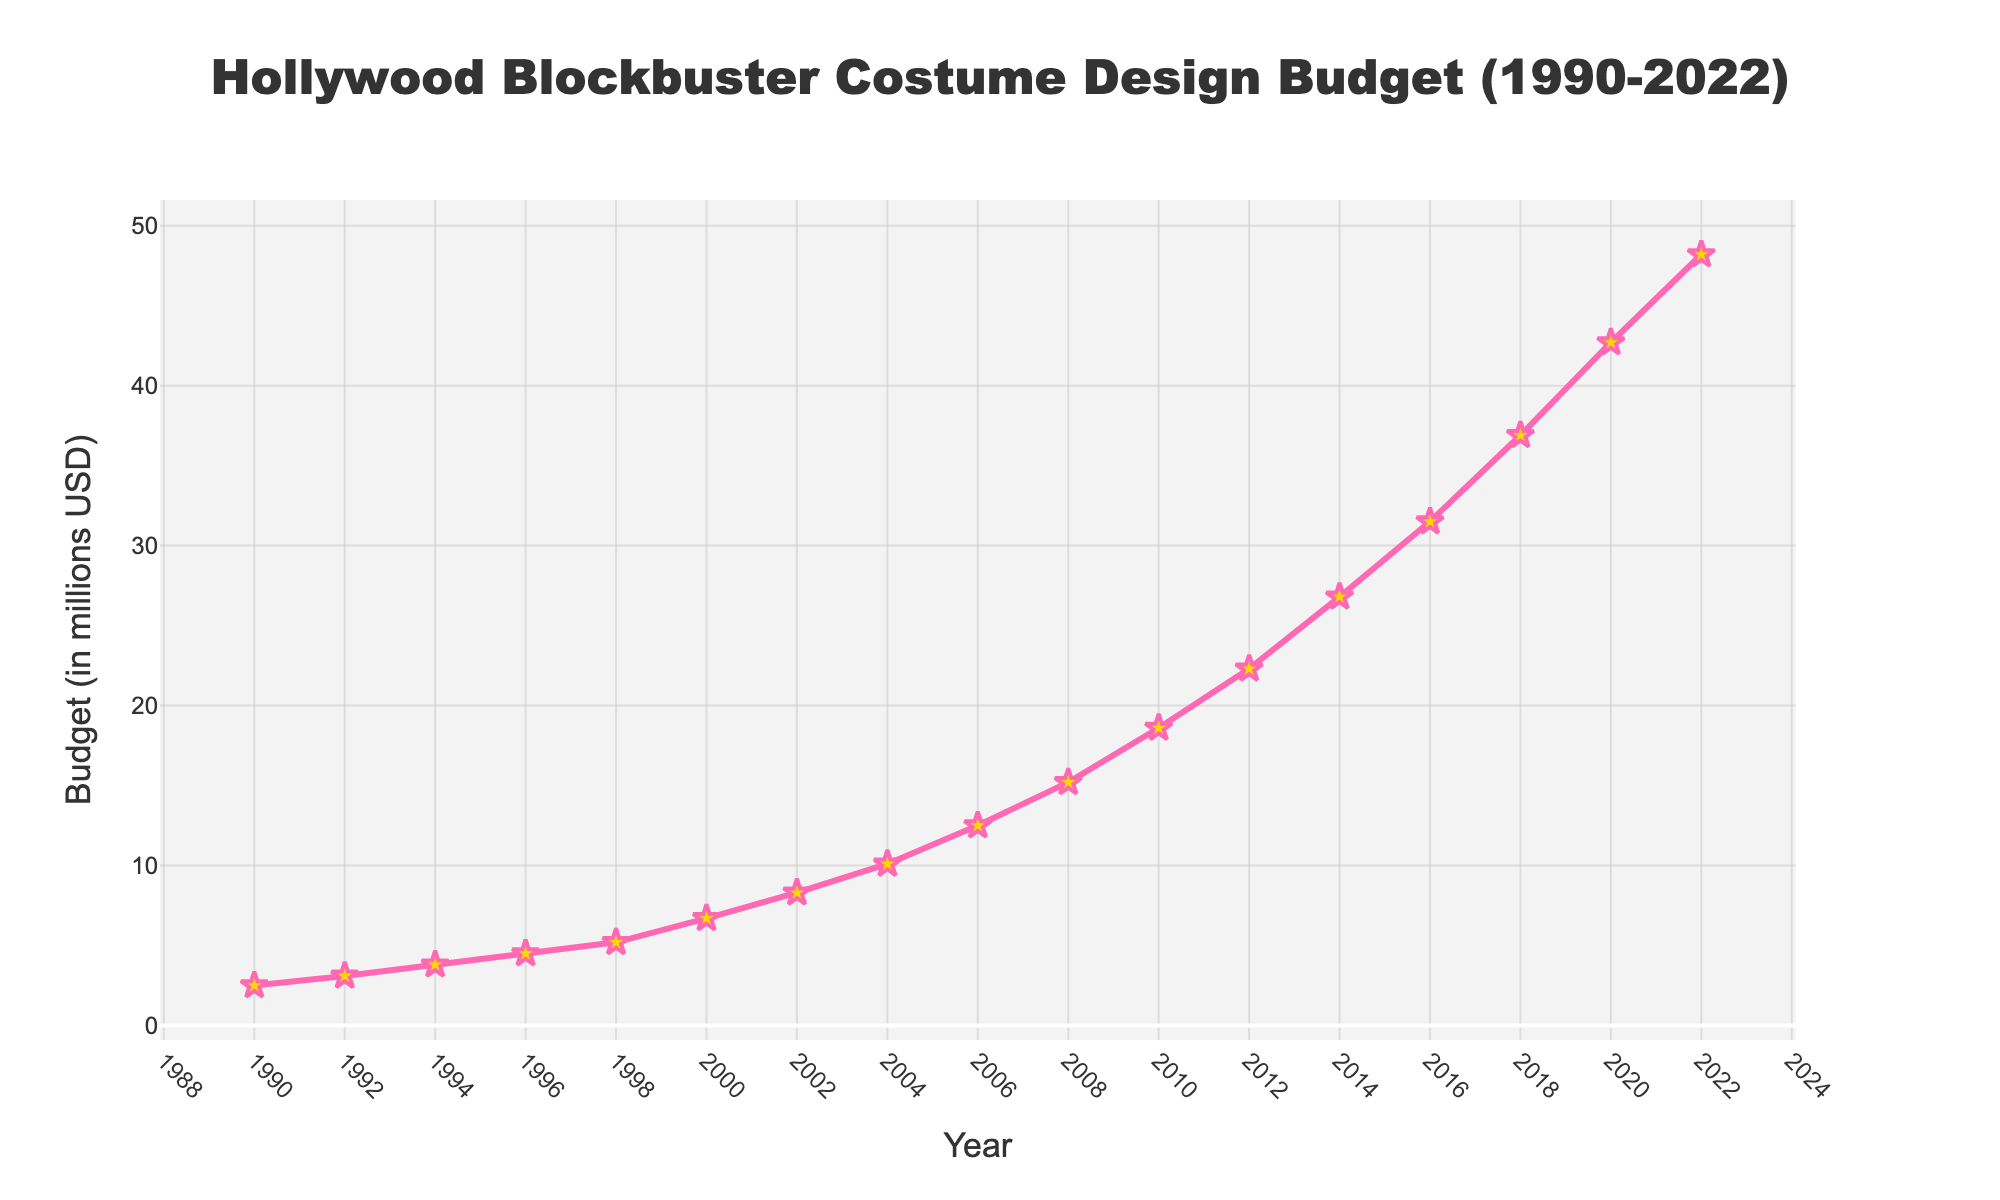What was the budget for costume design in 2004? Look at the year 2004 on the x-axis and find the corresponding value on the y-axis.
Answer: $10.1 million Which year saw the steepest increase in the budget for costume design? Look at the graph and find the segment of the line with the steepest upward slope. The slope is steepest between 2018 and 2020.
Answer: 2018-2020 By how much did the budget increase from 1990 to 2000? Find the budget values for 1990 and 2000, which are $2.5 million and $6.7 million, respectively. Subtract the 1990 value from the 2000 value: 6.7 - 2.5.
Answer: $4.2 million In which year did the budget first exceed $30 million? Look at the graph and find the first year where the y-axis value exceeds $30 million.
Answer: 2016 What is the average budget between 1990 and 2022? Sum all the budget values from 1990 to 2022 and divide by the number of years: (2.5 + 3.1 + 3.8 + 4.5 + 5.2 + 6.7 + 8.3 + 10.1 + 12.5 + 15.2 + 18.6 + 22.3 + 26.8 + 31.5 + 36.9 + 42.7 + 48.2) / 17.
Answer: $17.4 million How many times did the budget increase by more than $5 million compared to the previous data point? Compare each consecutive year's budget and count how many times the difference is greater than $5 million.
Answer: 5 times What is the median budget value from 1990 to 2022? Arrange the budget values in ascending order (2.5, 3.1, 3.8, 4.5, 5.2, 6.7, 8.3, 10.1, 12.5, 15.2, 18.6, 22.3, 26.8, 31.5, 36.9, 42.7, 48.2) and find the middle value. The 9th value in this ordered list is the median.
Answer: $12.5 million By what percentage did the budget increase from 2010 to 2022? Find the values for 2010 and 2022, which are $18.6 million and $48.2 million, respectively. Calculate the percentage increase: ((48.2 - 18.6) / 18.6) * 100.
Answer: 159.1% What is the range of the budget values from 1990 to 2022? Identify the highest and lowest values in the data set. The highest value is $48.2 million (2022) and the lowest is $2.5 million (1990). Subtract the lowest value from the highest: 48.2 - 2.5.
Answer: $45.7 million 